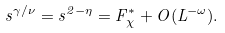Convert formula to latex. <formula><loc_0><loc_0><loc_500><loc_500>s ^ { \gamma / \nu } = s ^ { 2 - \eta } = F _ { \chi } ^ { * } + O ( L ^ { - \omega } ) .</formula> 